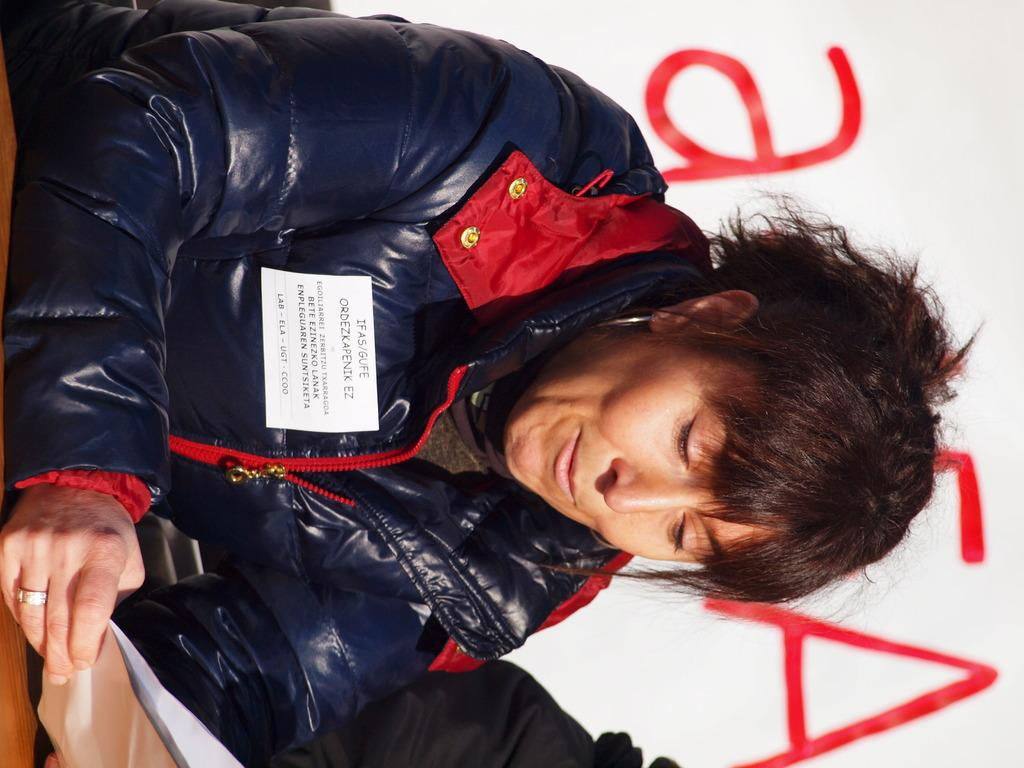Who is the main subject in the picture? There is a person in the center of the picture. What is the person wearing? The person is wearing a blue jacket. What is the person holding in their hands? The person is holding papers in their hands. What can be seen on the right side of the image? There is a banner on the right side of the image. Whose hand is visible at the bottom of the image? Another person's hand is visible at the bottom of the image. What type of sky is visible in the image? There is no sky visible in the image; it appears to be an indoor setting. What kind of trouble is the person in the blue jacket facing? There is no indication of trouble in the image; the person is simply holding papers. 